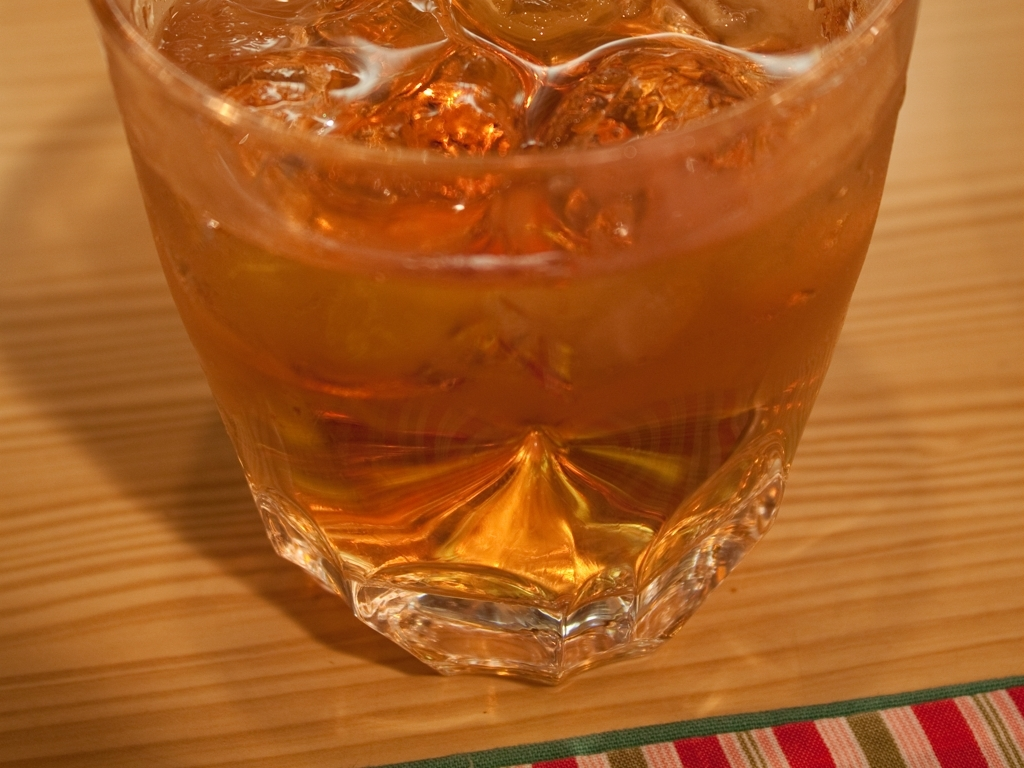The glass has a unique design. Can you tell me more about it? The glass features a geometric pattern at the bottom, with facets that resemble a crystal structure. This design not only enhances the visual appeal but may also provide a better grip. The geometric shape catches the light and projects an interesting play of reflections and refractions, adding to the aesthetic enjoyment of the beverage. 